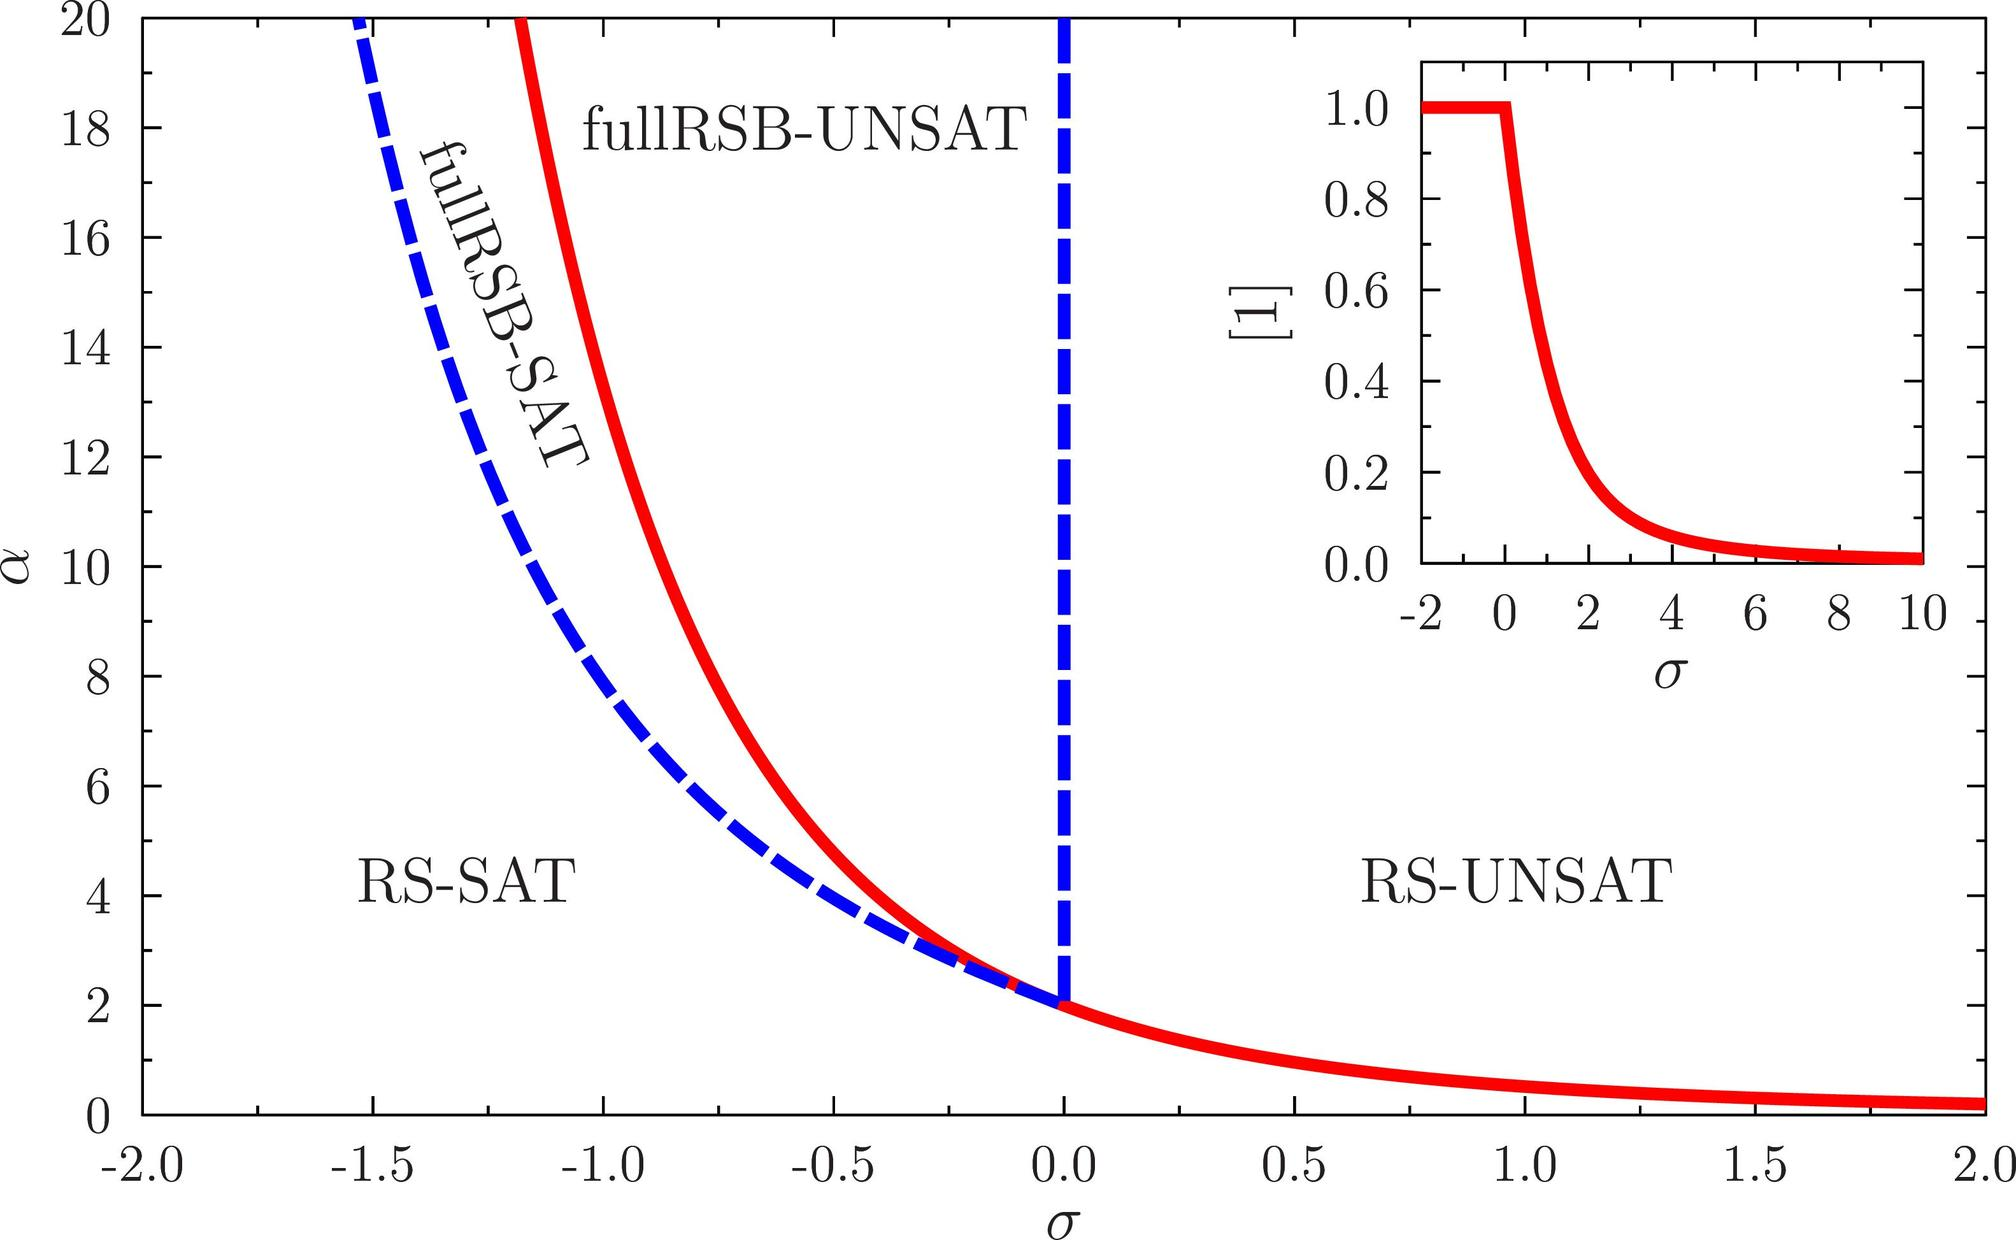Can you explain what the red curve on the graph indicates and why it curves the way it does? The red curve in the graph represents a boundary between different phases of satisfiability with respect to parameters α and σ. It shows a phase transition point where the conditions switch from satisfiable to unsatisfiable. The curvature of the red line reflects the changing behavior of the system as these parameters vary, illustrating the critical points beyond which the system can no longer maintain a satisfiable state due to increased complexity or constraints. 